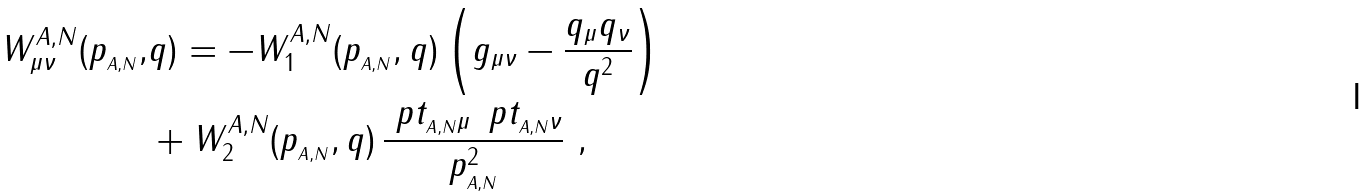<formula> <loc_0><loc_0><loc_500><loc_500>W ^ { A , N } _ { \mu \nu } ( p _ { _ { A , N } } , & q ) = - W ^ { A , N } _ { 1 } ( p _ { _ { A , N } } , q ) \left ( g _ { \mu \nu } - \frac { q _ { \mu } q _ { \nu } } { q ^ { 2 } } \right ) \\ & + W ^ { A , N } _ { 2 } ( p _ { _ { A , N } } , q ) \, \frac { \ p t _ { _ { A , N } \mu } \, \ p t _ { _ { A , N } \nu } } { p _ { _ { A , N } } ^ { 2 } } \ ,</formula> 